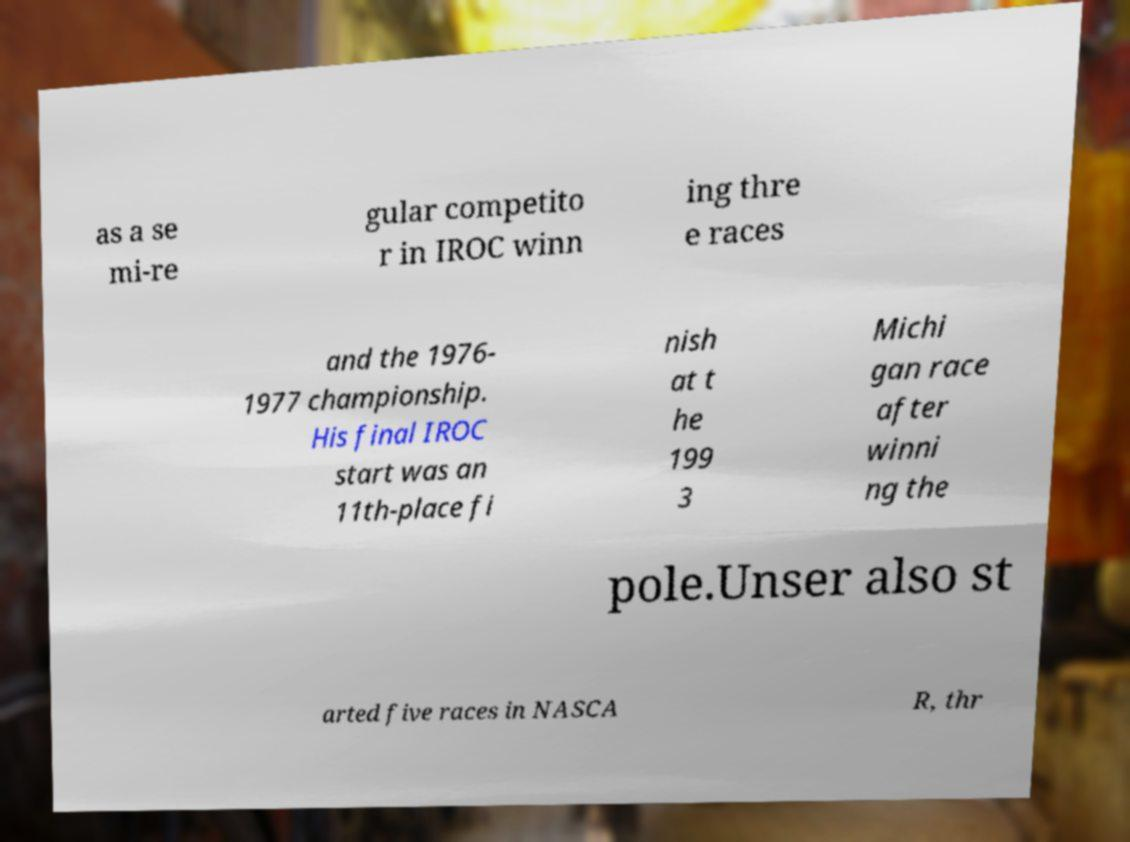Could you assist in decoding the text presented in this image and type it out clearly? as a se mi-re gular competito r in IROC winn ing thre e races and the 1976- 1977 championship. His final IROC start was an 11th-place fi nish at t he 199 3 Michi gan race after winni ng the pole.Unser also st arted five races in NASCA R, thr 